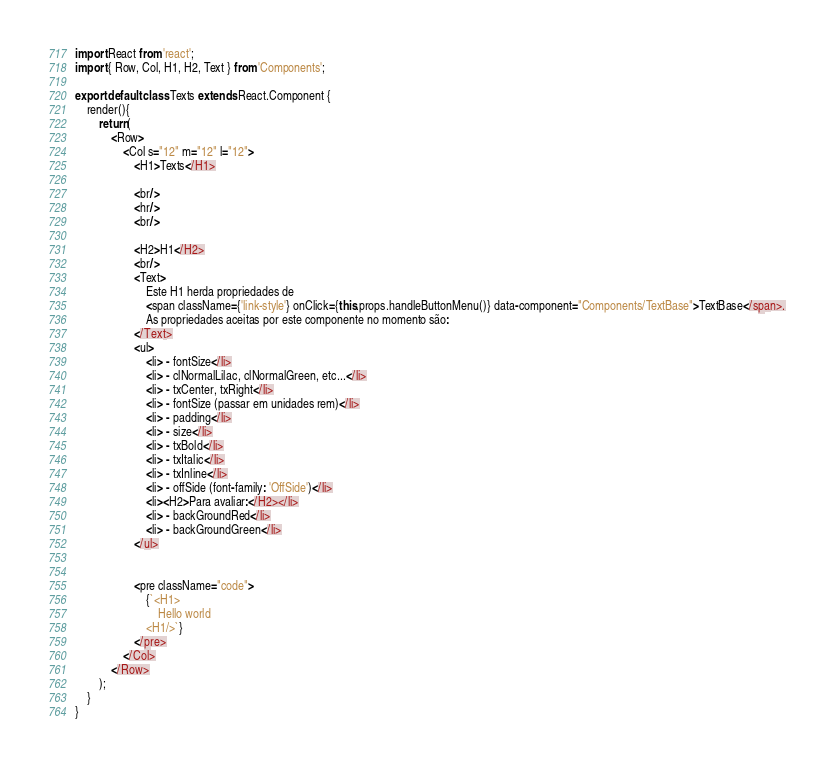Convert code to text. <code><loc_0><loc_0><loc_500><loc_500><_JavaScript_>import React from 'react';
import { Row, Col, H1, H2, Text } from 'Components';

export default class Texts extends React.Component {
	render(){
		return(
			<Row>
				<Col s="12" m="12" l="12">
					<H1>Texts</H1>

					<br/>
					<hr/>
					<br/>
					
					<H2>H1</H2>
					<br/>
					<Text>
						Este H1 herda propriedades de 
						<span className={'link-style'} onClick={this.props.handleButtonMenu()} data-component="Components/TextBase">TextBase</span>.
						As propriedades aceitas por este componente no momento são:
					</Text>
					<ul>
						<li> - fontSize</li>
						<li> - clNormalLilac, clNormalGreen, etc...</li>
						<li> - txCenter, txRight</li>
						<li> - fontSize (passar em unidades rem)</li>
						<li> - padding</li>
						<li> - size</li>
						<li> - txBold</li>
						<li> - txItalic</li>
						<li> - txInline</li>
						<li> - offSide (font-family: 'OffSide')</li>
						<li><H2>Para avaliar:</H2></li>
						<li> - backGroundRed</li>
						<li> - backGroundGreen</li>
					</ul>


					<pre className="code">
						{`<H1>
							Hello world
						<H1/>`}
					</pre>
				</Col>
			</Row>
		);
	}
}
</code> 